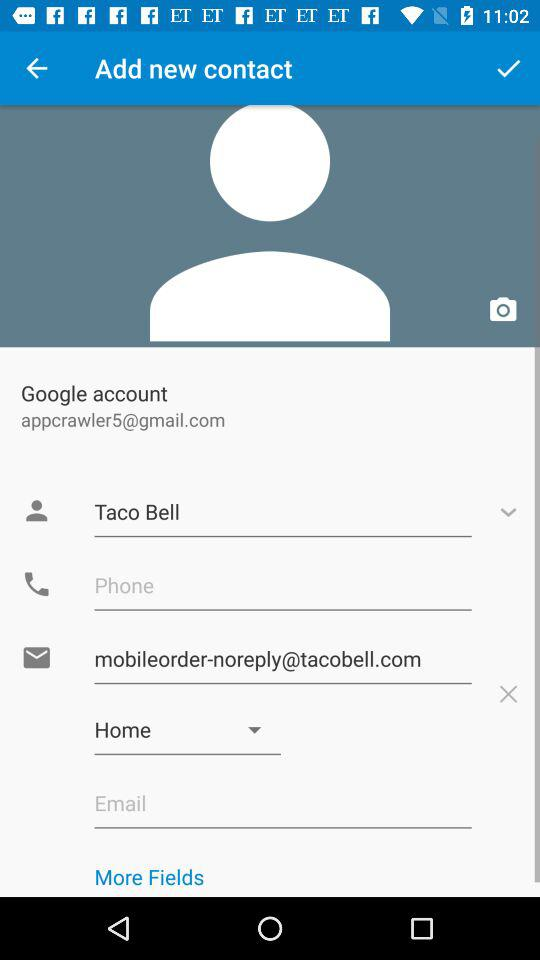Which address type is selected? The selected address type is "Home". 